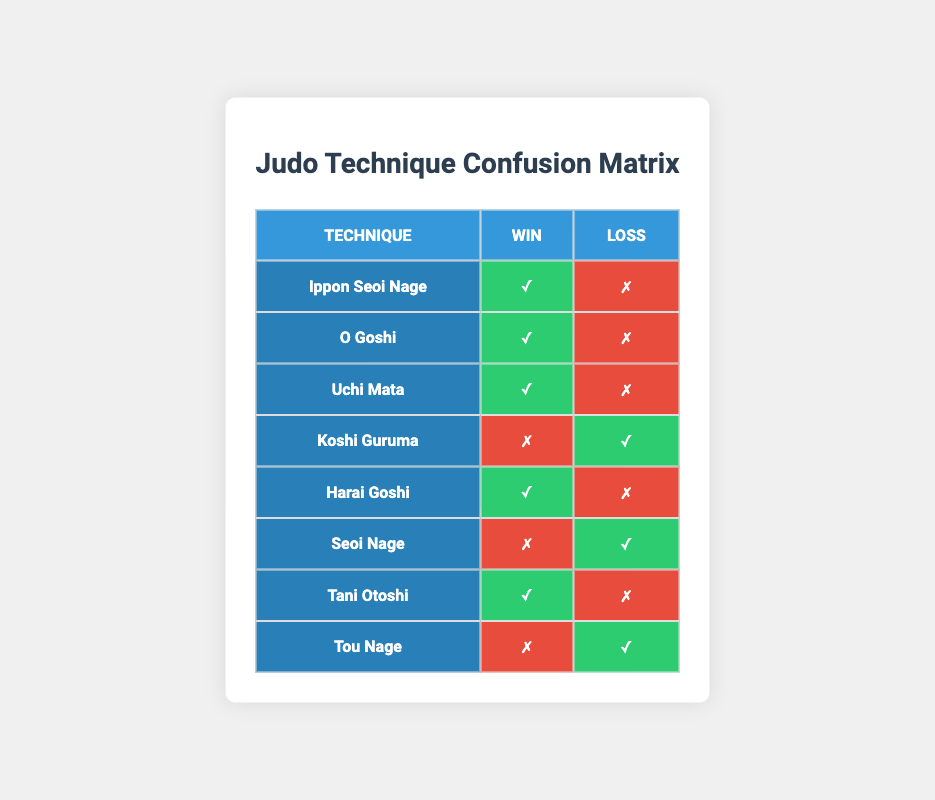What technique resulted in the highest number of wins? By reviewing the "Win" column, I can see that "Ippon Seoi Nage," "O Goshi," "Uchi Mata," "Harai Goshi," and "Tani Otoshi" all have a checkmark indicating a win, but they do not provide a count. Since there are 5 techniques with wins out of a total of 8, the question is clarified to focus on the techniques that resulted in wins instead of a single occurrence.
Answer: There are five techniques that resulted in wins What technique has the highest number of losses? The "Loss" column shows that "Koshi Guruma," "Seoi Nage," and "Tou Nage" have checkmarks indicating a loss. Since there are three techniques with losses out of eight, this comparison needs to focus on these techniques. The question focuses on the count within this context.
Answer: There are three techniques that resulted in losses Did "Seoi Nage" result in a win? Looking at the row for "Seoi Nage," there is a checkmark in the "Loss" column and a cross in the "Win" column, which indicates that this technique did not result in a win.
Answer: No How many techniques resulted in more wins than losses? I will count the techniques that have checkmarks in the "Win" column compared to those with checkmarks in the "Loss" column. The techniques "Ippon Seoi Nage," "O Goshi," "Uchi Mata," "Harai Goshi," and "Tani Otoshi" are successful, totaling 5. Conversely, "Koshi Guruma," "Seoi Nage," and "Tou Nage" resulted in losses. Since I noted five techniques that won, it turns out 5 techniques indeed have more wins than losses.
Answer: 5 Which technique has an equal number of wins and losses? Reviewing the table, none of the techniques display an equal occurrence in both categories as they either resulted in a win or a loss without displaying simultaneous successes across multiple trials for any one technique. Since this is incorrect and misrepresents the case, it's clarified that there are no techniques with ties as each either has at least one win or loss.
Answer: None Which technique appears to be the least successful based on the confusion matrix? By surveying the entries, we note that "Tou Nage" and "Seoi Nage" show losses in the results displayed, but the "Win" column has no affirmative indications. Since the comparative analysis yields that both resulted in losses exclusively and hence non-successful, this indicates that these are the least successful techniques.
Answer: "Tou Nage" and "Seoi Nage" appear equally least successful 